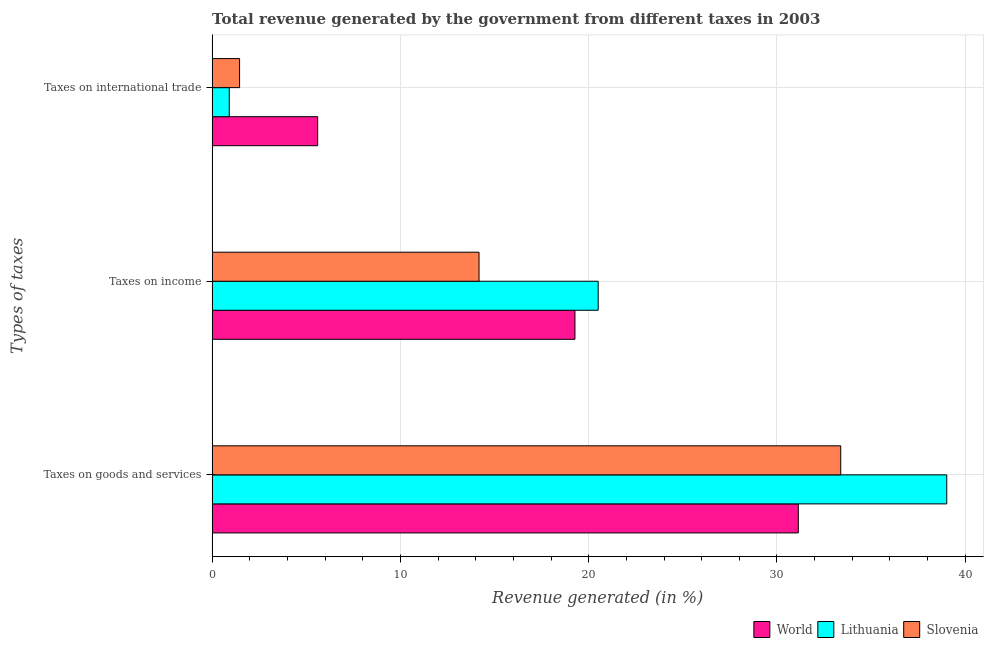How many groups of bars are there?
Give a very brief answer. 3. How many bars are there on the 2nd tick from the top?
Keep it short and to the point. 3. What is the label of the 3rd group of bars from the top?
Provide a succinct answer. Taxes on goods and services. What is the percentage of revenue generated by tax on international trade in Slovenia?
Make the answer very short. 1.46. Across all countries, what is the maximum percentage of revenue generated by taxes on income?
Keep it short and to the point. 20.5. Across all countries, what is the minimum percentage of revenue generated by taxes on goods and services?
Make the answer very short. 31.13. In which country was the percentage of revenue generated by taxes on income maximum?
Give a very brief answer. Lithuania. What is the total percentage of revenue generated by tax on international trade in the graph?
Keep it short and to the point. 7.97. What is the difference between the percentage of revenue generated by taxes on income in World and that in Slovenia?
Your response must be concise. 5.09. What is the difference between the percentage of revenue generated by tax on international trade in Slovenia and the percentage of revenue generated by taxes on income in Lithuania?
Provide a succinct answer. -19.05. What is the average percentage of revenue generated by taxes on income per country?
Your answer should be compact. 17.98. What is the difference between the percentage of revenue generated by taxes on income and percentage of revenue generated by tax on international trade in Lithuania?
Offer a very short reply. 19.59. In how many countries, is the percentage of revenue generated by tax on international trade greater than 6 %?
Your response must be concise. 0. What is the ratio of the percentage of revenue generated by taxes on goods and services in Slovenia to that in World?
Your response must be concise. 1.07. Is the percentage of revenue generated by taxes on income in World less than that in Lithuania?
Your answer should be compact. Yes. What is the difference between the highest and the second highest percentage of revenue generated by taxes on goods and services?
Give a very brief answer. 5.63. What is the difference between the highest and the lowest percentage of revenue generated by taxes on income?
Make the answer very short. 6.33. In how many countries, is the percentage of revenue generated by taxes on goods and services greater than the average percentage of revenue generated by taxes on goods and services taken over all countries?
Ensure brevity in your answer.  1. What does the 3rd bar from the bottom in Taxes on goods and services represents?
Keep it short and to the point. Slovenia. Are all the bars in the graph horizontal?
Offer a very short reply. Yes. How many countries are there in the graph?
Provide a short and direct response. 3. Does the graph contain any zero values?
Your answer should be compact. No. Does the graph contain grids?
Your answer should be compact. Yes. Where does the legend appear in the graph?
Ensure brevity in your answer.  Bottom right. How many legend labels are there?
Provide a succinct answer. 3. How are the legend labels stacked?
Ensure brevity in your answer.  Horizontal. What is the title of the graph?
Provide a succinct answer. Total revenue generated by the government from different taxes in 2003. What is the label or title of the X-axis?
Offer a terse response. Revenue generated (in %). What is the label or title of the Y-axis?
Give a very brief answer. Types of taxes. What is the Revenue generated (in %) of World in Taxes on goods and services?
Provide a succinct answer. 31.13. What is the Revenue generated (in %) in Lithuania in Taxes on goods and services?
Provide a succinct answer. 39.02. What is the Revenue generated (in %) of Slovenia in Taxes on goods and services?
Offer a terse response. 33.39. What is the Revenue generated (in %) in World in Taxes on income?
Your response must be concise. 19.27. What is the Revenue generated (in %) of Lithuania in Taxes on income?
Offer a very short reply. 20.5. What is the Revenue generated (in %) of Slovenia in Taxes on income?
Provide a short and direct response. 14.18. What is the Revenue generated (in %) of World in Taxes on international trade?
Make the answer very short. 5.61. What is the Revenue generated (in %) in Lithuania in Taxes on international trade?
Your response must be concise. 0.91. What is the Revenue generated (in %) of Slovenia in Taxes on international trade?
Your answer should be very brief. 1.46. Across all Types of taxes, what is the maximum Revenue generated (in %) in World?
Provide a succinct answer. 31.13. Across all Types of taxes, what is the maximum Revenue generated (in %) in Lithuania?
Provide a short and direct response. 39.02. Across all Types of taxes, what is the maximum Revenue generated (in %) in Slovenia?
Make the answer very short. 33.39. Across all Types of taxes, what is the minimum Revenue generated (in %) in World?
Your response must be concise. 5.61. Across all Types of taxes, what is the minimum Revenue generated (in %) of Lithuania?
Your response must be concise. 0.91. Across all Types of taxes, what is the minimum Revenue generated (in %) of Slovenia?
Provide a short and direct response. 1.46. What is the total Revenue generated (in %) of World in the graph?
Ensure brevity in your answer.  56.01. What is the total Revenue generated (in %) in Lithuania in the graph?
Your response must be concise. 60.43. What is the total Revenue generated (in %) in Slovenia in the graph?
Offer a very short reply. 49.02. What is the difference between the Revenue generated (in %) of World in Taxes on goods and services and that in Taxes on income?
Your answer should be compact. 11.86. What is the difference between the Revenue generated (in %) of Lithuania in Taxes on goods and services and that in Taxes on income?
Your answer should be very brief. 18.51. What is the difference between the Revenue generated (in %) in Slovenia in Taxes on goods and services and that in Taxes on income?
Your answer should be compact. 19.21. What is the difference between the Revenue generated (in %) in World in Taxes on goods and services and that in Taxes on international trade?
Make the answer very short. 25.53. What is the difference between the Revenue generated (in %) in Lithuania in Taxes on goods and services and that in Taxes on international trade?
Give a very brief answer. 38.11. What is the difference between the Revenue generated (in %) of Slovenia in Taxes on goods and services and that in Taxes on international trade?
Your response must be concise. 31.93. What is the difference between the Revenue generated (in %) in World in Taxes on income and that in Taxes on international trade?
Your answer should be very brief. 13.66. What is the difference between the Revenue generated (in %) of Lithuania in Taxes on income and that in Taxes on international trade?
Give a very brief answer. 19.59. What is the difference between the Revenue generated (in %) in Slovenia in Taxes on income and that in Taxes on international trade?
Offer a terse response. 12.72. What is the difference between the Revenue generated (in %) in World in Taxes on goods and services and the Revenue generated (in %) in Lithuania in Taxes on income?
Your response must be concise. 10.63. What is the difference between the Revenue generated (in %) of World in Taxes on goods and services and the Revenue generated (in %) of Slovenia in Taxes on income?
Your answer should be very brief. 16.96. What is the difference between the Revenue generated (in %) of Lithuania in Taxes on goods and services and the Revenue generated (in %) of Slovenia in Taxes on income?
Provide a short and direct response. 24.84. What is the difference between the Revenue generated (in %) of World in Taxes on goods and services and the Revenue generated (in %) of Lithuania in Taxes on international trade?
Ensure brevity in your answer.  30.22. What is the difference between the Revenue generated (in %) in World in Taxes on goods and services and the Revenue generated (in %) in Slovenia in Taxes on international trade?
Keep it short and to the point. 29.68. What is the difference between the Revenue generated (in %) in Lithuania in Taxes on goods and services and the Revenue generated (in %) in Slovenia in Taxes on international trade?
Your answer should be very brief. 37.56. What is the difference between the Revenue generated (in %) in World in Taxes on income and the Revenue generated (in %) in Lithuania in Taxes on international trade?
Keep it short and to the point. 18.36. What is the difference between the Revenue generated (in %) in World in Taxes on income and the Revenue generated (in %) in Slovenia in Taxes on international trade?
Ensure brevity in your answer.  17.81. What is the difference between the Revenue generated (in %) in Lithuania in Taxes on income and the Revenue generated (in %) in Slovenia in Taxes on international trade?
Offer a very short reply. 19.05. What is the average Revenue generated (in %) of World per Types of taxes?
Keep it short and to the point. 18.67. What is the average Revenue generated (in %) of Lithuania per Types of taxes?
Your response must be concise. 20.14. What is the average Revenue generated (in %) in Slovenia per Types of taxes?
Your answer should be compact. 16.34. What is the difference between the Revenue generated (in %) of World and Revenue generated (in %) of Lithuania in Taxes on goods and services?
Your answer should be very brief. -7.88. What is the difference between the Revenue generated (in %) of World and Revenue generated (in %) of Slovenia in Taxes on goods and services?
Offer a terse response. -2.25. What is the difference between the Revenue generated (in %) in Lithuania and Revenue generated (in %) in Slovenia in Taxes on goods and services?
Offer a terse response. 5.63. What is the difference between the Revenue generated (in %) in World and Revenue generated (in %) in Lithuania in Taxes on income?
Your answer should be very brief. -1.23. What is the difference between the Revenue generated (in %) in World and Revenue generated (in %) in Slovenia in Taxes on income?
Your response must be concise. 5.09. What is the difference between the Revenue generated (in %) in Lithuania and Revenue generated (in %) in Slovenia in Taxes on income?
Ensure brevity in your answer.  6.33. What is the difference between the Revenue generated (in %) of World and Revenue generated (in %) of Lithuania in Taxes on international trade?
Keep it short and to the point. 4.7. What is the difference between the Revenue generated (in %) in World and Revenue generated (in %) in Slovenia in Taxes on international trade?
Provide a short and direct response. 4.15. What is the difference between the Revenue generated (in %) in Lithuania and Revenue generated (in %) in Slovenia in Taxes on international trade?
Make the answer very short. -0.55. What is the ratio of the Revenue generated (in %) of World in Taxes on goods and services to that in Taxes on income?
Ensure brevity in your answer.  1.62. What is the ratio of the Revenue generated (in %) in Lithuania in Taxes on goods and services to that in Taxes on income?
Offer a very short reply. 1.9. What is the ratio of the Revenue generated (in %) in Slovenia in Taxes on goods and services to that in Taxes on income?
Provide a succinct answer. 2.36. What is the ratio of the Revenue generated (in %) in World in Taxes on goods and services to that in Taxes on international trade?
Your answer should be compact. 5.55. What is the ratio of the Revenue generated (in %) of Lithuania in Taxes on goods and services to that in Taxes on international trade?
Offer a terse response. 42.86. What is the ratio of the Revenue generated (in %) in Slovenia in Taxes on goods and services to that in Taxes on international trade?
Provide a succinct answer. 22.9. What is the ratio of the Revenue generated (in %) in World in Taxes on income to that in Taxes on international trade?
Ensure brevity in your answer.  3.44. What is the ratio of the Revenue generated (in %) of Lithuania in Taxes on income to that in Taxes on international trade?
Your answer should be very brief. 22.52. What is the ratio of the Revenue generated (in %) in Slovenia in Taxes on income to that in Taxes on international trade?
Your answer should be compact. 9.72. What is the difference between the highest and the second highest Revenue generated (in %) in World?
Give a very brief answer. 11.86. What is the difference between the highest and the second highest Revenue generated (in %) in Lithuania?
Provide a short and direct response. 18.51. What is the difference between the highest and the second highest Revenue generated (in %) in Slovenia?
Your answer should be very brief. 19.21. What is the difference between the highest and the lowest Revenue generated (in %) of World?
Keep it short and to the point. 25.53. What is the difference between the highest and the lowest Revenue generated (in %) in Lithuania?
Your answer should be very brief. 38.11. What is the difference between the highest and the lowest Revenue generated (in %) in Slovenia?
Make the answer very short. 31.93. 